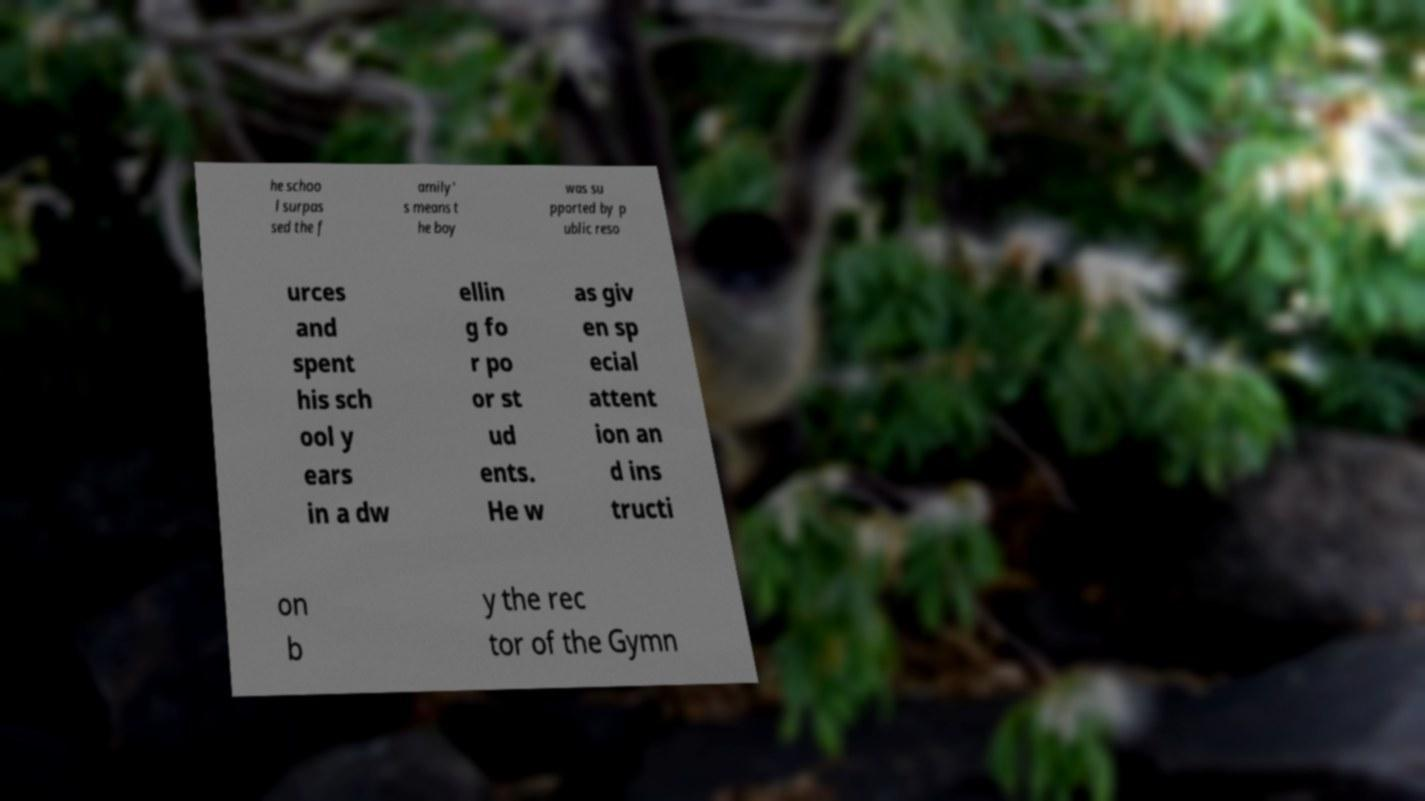For documentation purposes, I need the text within this image transcribed. Could you provide that? he schoo l surpas sed the f amily' s means t he boy was su pported by p ublic reso urces and spent his sch ool y ears in a dw ellin g fo r po or st ud ents. He w as giv en sp ecial attent ion an d ins tructi on b y the rec tor of the Gymn 